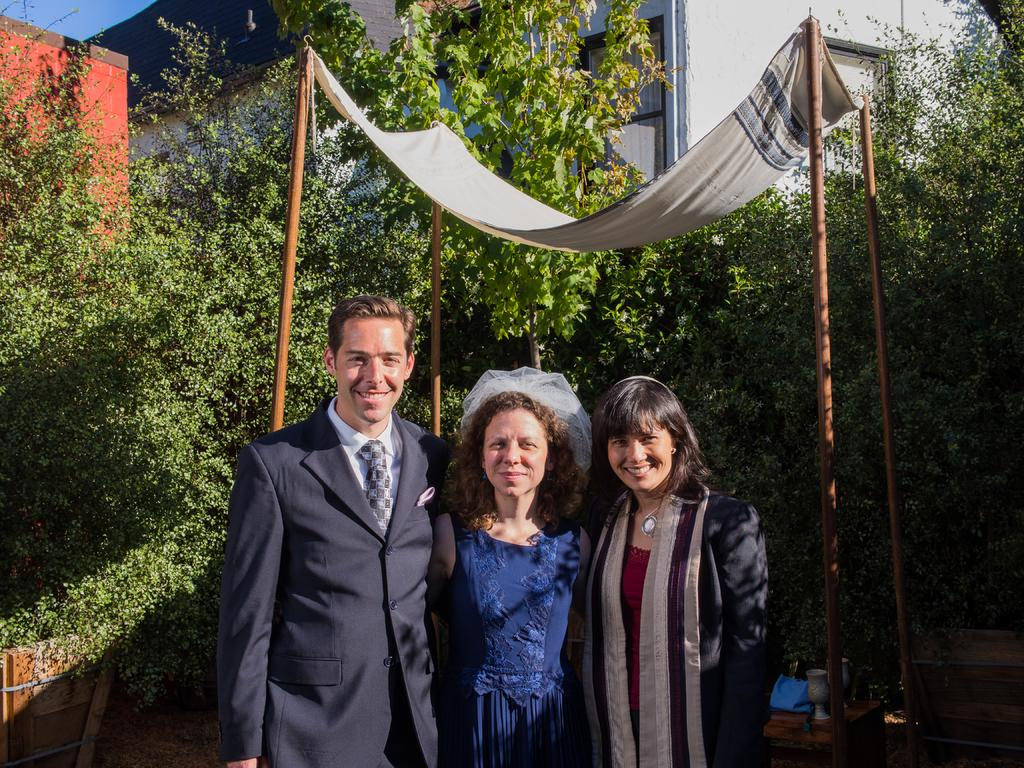How many people are in the image? There are three persons in the image. What is holding the cloth in the image? There are four sticks holding a cloth in the image. How many vases can be seen in the image? There are two vases in the image. What type of natural elements are visible in the image? Trees are visible in the image. What type of man-made structures can be seen in the image? Buildings are visible in the image. What type of kite is being flown by the person on the left in the image? There is no kite visible in the image; it only shows three persons, four sticks holding a cloth, two vases, trees, and buildings. How many oranges are on the table in the image? There is no table or oranges present in the image. 